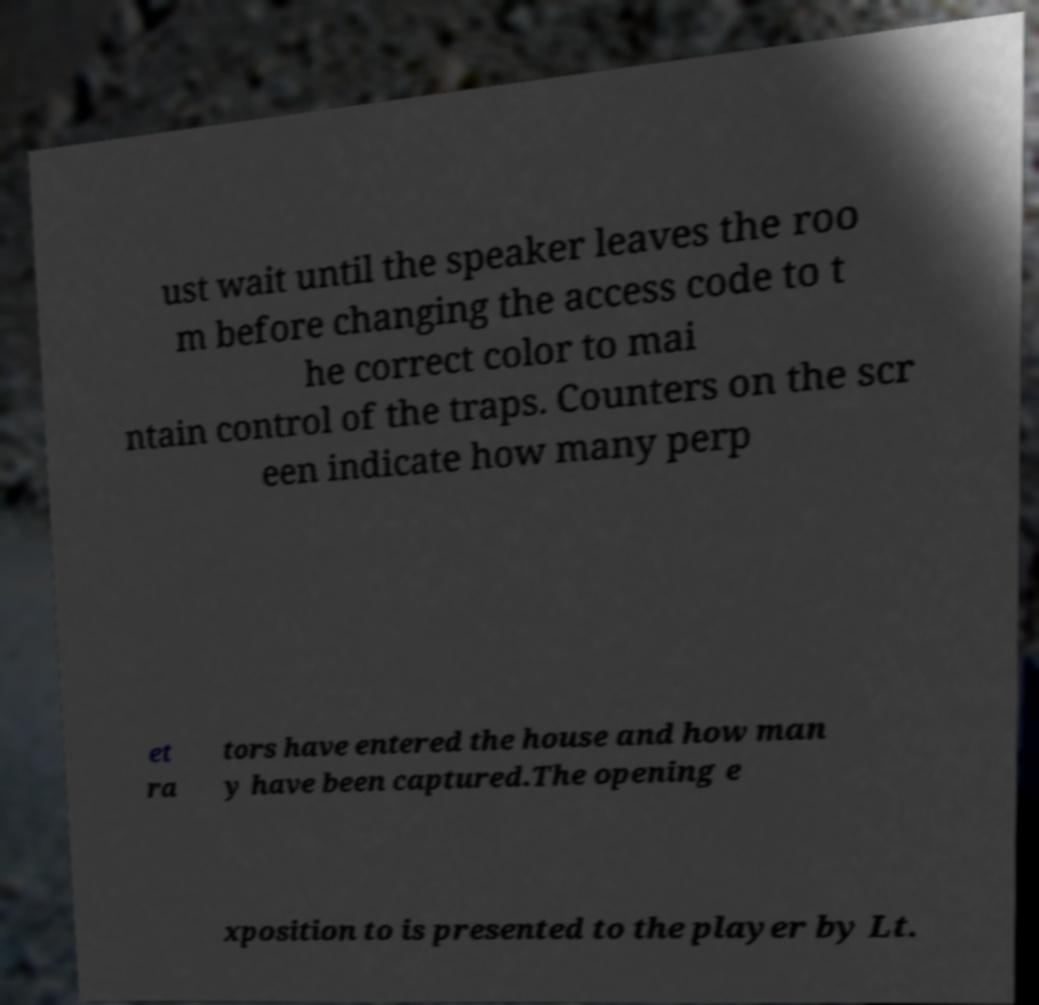Please read and relay the text visible in this image. What does it say? ust wait until the speaker leaves the roo m before changing the access code to t he correct color to mai ntain control of the traps. Counters on the scr een indicate how many perp et ra tors have entered the house and how man y have been captured.The opening e xposition to is presented to the player by Lt. 